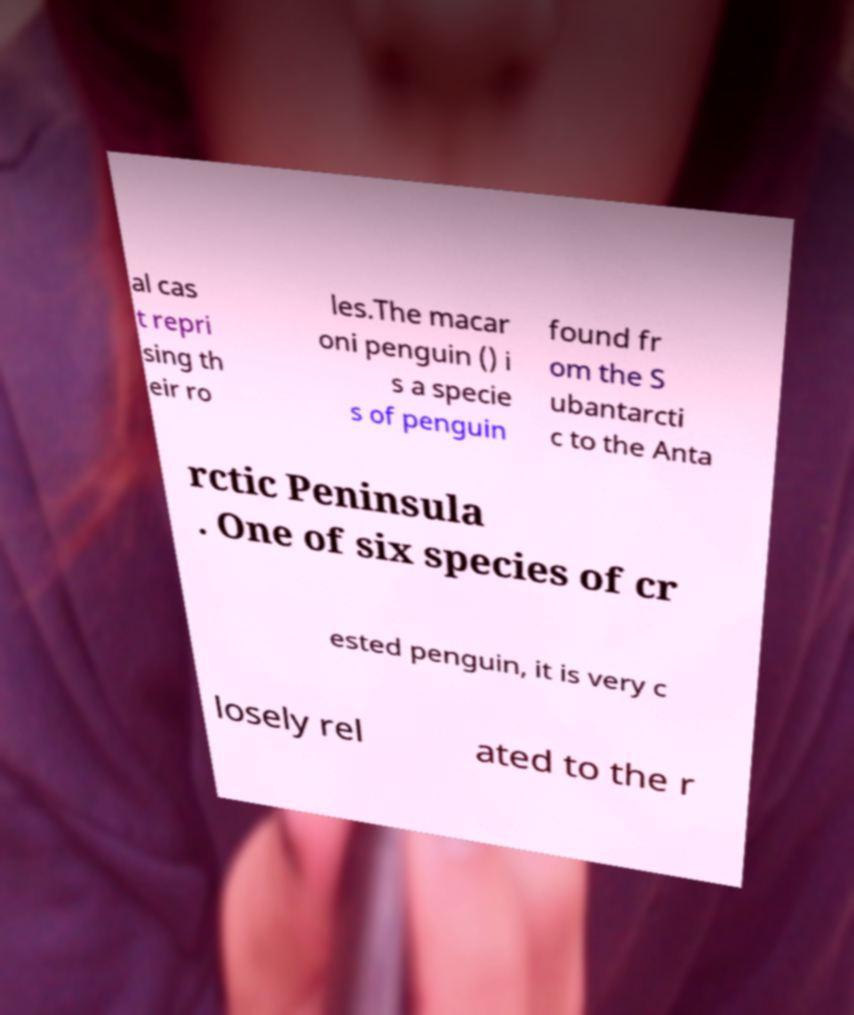Can you read and provide the text displayed in the image?This photo seems to have some interesting text. Can you extract and type it out for me? al cas t repri sing th eir ro les.The macar oni penguin () i s a specie s of penguin found fr om the S ubantarcti c to the Anta rctic Peninsula . One of six species of cr ested penguin, it is very c losely rel ated to the r 